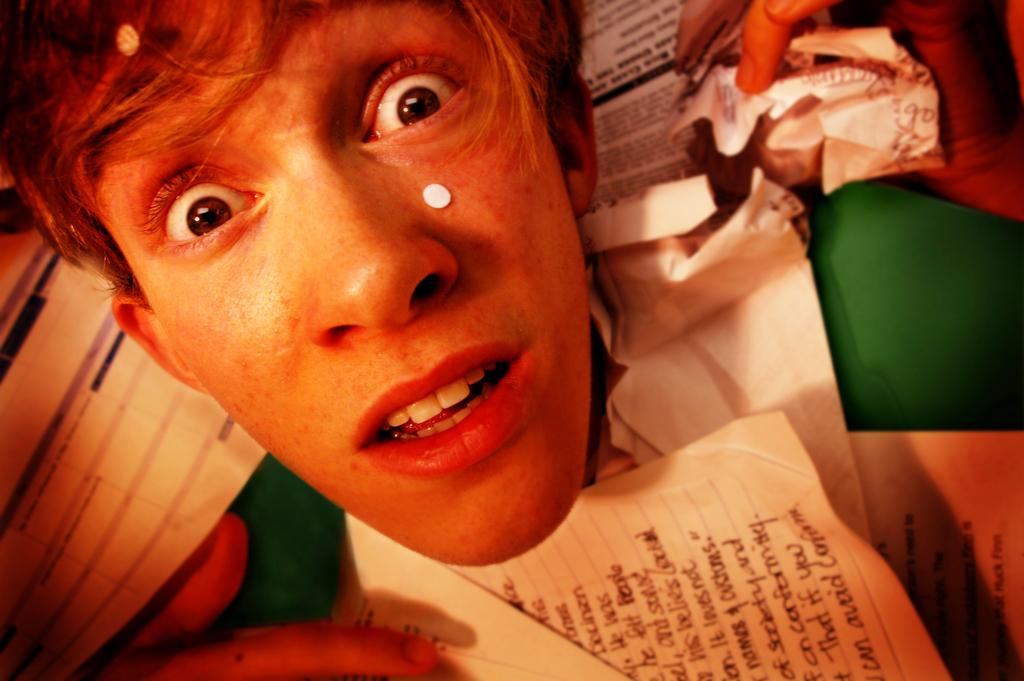Who is present in the image? There is a boy in the image. What objects can be seen in the image? There are papers in the image. Are there any baby fairies playing in the houses in the image? There is no mention of baby fairies or houses in the image; it only features a boy and papers. 